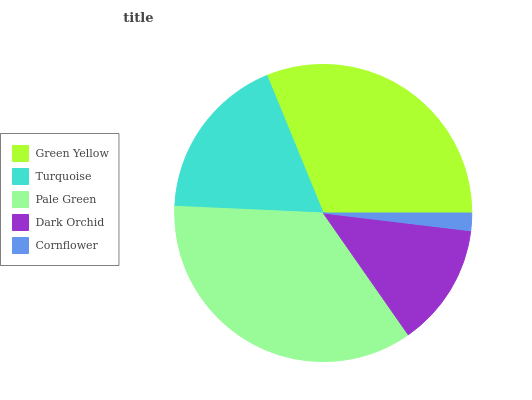Is Cornflower the minimum?
Answer yes or no. Yes. Is Pale Green the maximum?
Answer yes or no. Yes. Is Turquoise the minimum?
Answer yes or no. No. Is Turquoise the maximum?
Answer yes or no. No. Is Green Yellow greater than Turquoise?
Answer yes or no. Yes. Is Turquoise less than Green Yellow?
Answer yes or no. Yes. Is Turquoise greater than Green Yellow?
Answer yes or no. No. Is Green Yellow less than Turquoise?
Answer yes or no. No. Is Turquoise the high median?
Answer yes or no. Yes. Is Turquoise the low median?
Answer yes or no. Yes. Is Pale Green the high median?
Answer yes or no. No. Is Pale Green the low median?
Answer yes or no. No. 